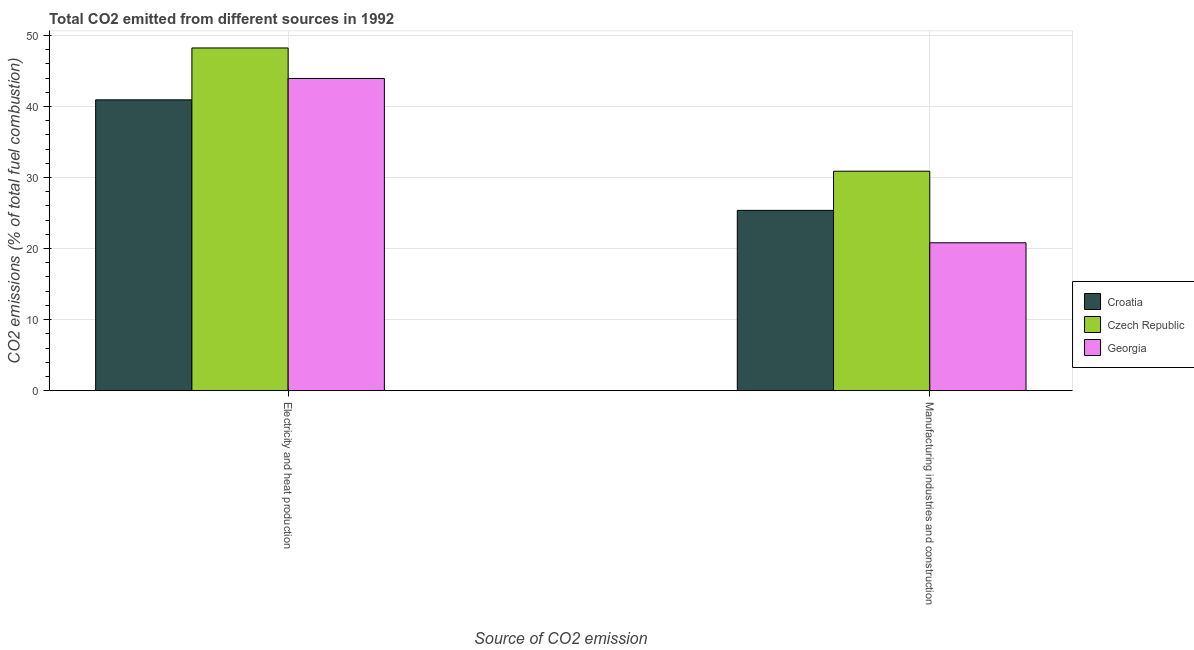How many different coloured bars are there?
Make the answer very short. 3. How many groups of bars are there?
Provide a short and direct response. 2. Are the number of bars per tick equal to the number of legend labels?
Make the answer very short. Yes. Are the number of bars on each tick of the X-axis equal?
Keep it short and to the point. Yes. What is the label of the 2nd group of bars from the left?
Provide a short and direct response. Manufacturing industries and construction. What is the co2 emissions due to electricity and heat production in Czech Republic?
Provide a succinct answer. 48.24. Across all countries, what is the maximum co2 emissions due to manufacturing industries?
Your response must be concise. 30.89. Across all countries, what is the minimum co2 emissions due to electricity and heat production?
Ensure brevity in your answer.  40.94. In which country was the co2 emissions due to manufacturing industries maximum?
Offer a very short reply. Czech Republic. In which country was the co2 emissions due to manufacturing industries minimum?
Your answer should be very brief. Georgia. What is the total co2 emissions due to electricity and heat production in the graph?
Offer a very short reply. 133.12. What is the difference between the co2 emissions due to manufacturing industries in Czech Republic and that in Croatia?
Provide a succinct answer. 5.51. What is the difference between the co2 emissions due to manufacturing industries in Georgia and the co2 emissions due to electricity and heat production in Czech Republic?
Provide a short and direct response. -27.43. What is the average co2 emissions due to manufacturing industries per country?
Keep it short and to the point. 25.69. What is the difference between the co2 emissions due to manufacturing industries and co2 emissions due to electricity and heat production in Czech Republic?
Your answer should be compact. -17.35. What is the ratio of the co2 emissions due to manufacturing industries in Czech Republic to that in Croatia?
Provide a short and direct response. 1.22. Is the co2 emissions due to manufacturing industries in Georgia less than that in Czech Republic?
Make the answer very short. Yes. What does the 1st bar from the left in Manufacturing industries and construction represents?
Make the answer very short. Croatia. What does the 2nd bar from the right in Electricity and heat production represents?
Your response must be concise. Czech Republic. Where does the legend appear in the graph?
Offer a very short reply. Center right. How many legend labels are there?
Keep it short and to the point. 3. What is the title of the graph?
Provide a short and direct response. Total CO2 emitted from different sources in 1992. What is the label or title of the X-axis?
Keep it short and to the point. Source of CO2 emission. What is the label or title of the Y-axis?
Your response must be concise. CO2 emissions (% of total fuel combustion). What is the CO2 emissions (% of total fuel combustion) of Croatia in Electricity and heat production?
Offer a very short reply. 40.94. What is the CO2 emissions (% of total fuel combustion) of Czech Republic in Electricity and heat production?
Offer a very short reply. 48.24. What is the CO2 emissions (% of total fuel combustion) of Georgia in Electricity and heat production?
Offer a terse response. 43.94. What is the CO2 emissions (% of total fuel combustion) of Croatia in Manufacturing industries and construction?
Keep it short and to the point. 25.38. What is the CO2 emissions (% of total fuel combustion) in Czech Republic in Manufacturing industries and construction?
Your answer should be compact. 30.89. What is the CO2 emissions (% of total fuel combustion) of Georgia in Manufacturing industries and construction?
Provide a succinct answer. 20.81. Across all Source of CO2 emission, what is the maximum CO2 emissions (% of total fuel combustion) in Croatia?
Provide a short and direct response. 40.94. Across all Source of CO2 emission, what is the maximum CO2 emissions (% of total fuel combustion) of Czech Republic?
Your response must be concise. 48.24. Across all Source of CO2 emission, what is the maximum CO2 emissions (% of total fuel combustion) of Georgia?
Make the answer very short. 43.94. Across all Source of CO2 emission, what is the minimum CO2 emissions (% of total fuel combustion) of Croatia?
Offer a terse response. 25.38. Across all Source of CO2 emission, what is the minimum CO2 emissions (% of total fuel combustion) in Czech Republic?
Keep it short and to the point. 30.89. Across all Source of CO2 emission, what is the minimum CO2 emissions (% of total fuel combustion) in Georgia?
Offer a terse response. 20.81. What is the total CO2 emissions (% of total fuel combustion) in Croatia in the graph?
Keep it short and to the point. 66.32. What is the total CO2 emissions (% of total fuel combustion) of Czech Republic in the graph?
Ensure brevity in your answer.  79.13. What is the total CO2 emissions (% of total fuel combustion) in Georgia in the graph?
Offer a very short reply. 64.76. What is the difference between the CO2 emissions (% of total fuel combustion) of Croatia in Electricity and heat production and that in Manufacturing industries and construction?
Make the answer very short. 15.56. What is the difference between the CO2 emissions (% of total fuel combustion) in Czech Republic in Electricity and heat production and that in Manufacturing industries and construction?
Provide a short and direct response. 17.35. What is the difference between the CO2 emissions (% of total fuel combustion) in Georgia in Electricity and heat production and that in Manufacturing industries and construction?
Your answer should be compact. 23.13. What is the difference between the CO2 emissions (% of total fuel combustion) in Croatia in Electricity and heat production and the CO2 emissions (% of total fuel combustion) in Czech Republic in Manufacturing industries and construction?
Keep it short and to the point. 10.05. What is the difference between the CO2 emissions (% of total fuel combustion) of Croatia in Electricity and heat production and the CO2 emissions (% of total fuel combustion) of Georgia in Manufacturing industries and construction?
Your answer should be very brief. 20.12. What is the difference between the CO2 emissions (% of total fuel combustion) in Czech Republic in Electricity and heat production and the CO2 emissions (% of total fuel combustion) in Georgia in Manufacturing industries and construction?
Keep it short and to the point. 27.43. What is the average CO2 emissions (% of total fuel combustion) in Croatia per Source of CO2 emission?
Your answer should be very brief. 33.16. What is the average CO2 emissions (% of total fuel combustion) in Czech Republic per Source of CO2 emission?
Make the answer very short. 39.57. What is the average CO2 emissions (% of total fuel combustion) of Georgia per Source of CO2 emission?
Offer a terse response. 32.38. What is the difference between the CO2 emissions (% of total fuel combustion) in Croatia and CO2 emissions (% of total fuel combustion) in Czech Republic in Electricity and heat production?
Ensure brevity in your answer.  -7.3. What is the difference between the CO2 emissions (% of total fuel combustion) in Croatia and CO2 emissions (% of total fuel combustion) in Georgia in Electricity and heat production?
Ensure brevity in your answer.  -3.01. What is the difference between the CO2 emissions (% of total fuel combustion) of Czech Republic and CO2 emissions (% of total fuel combustion) of Georgia in Electricity and heat production?
Offer a very short reply. 4.3. What is the difference between the CO2 emissions (% of total fuel combustion) of Croatia and CO2 emissions (% of total fuel combustion) of Czech Republic in Manufacturing industries and construction?
Provide a succinct answer. -5.51. What is the difference between the CO2 emissions (% of total fuel combustion) of Croatia and CO2 emissions (% of total fuel combustion) of Georgia in Manufacturing industries and construction?
Provide a succinct answer. 4.56. What is the difference between the CO2 emissions (% of total fuel combustion) in Czech Republic and CO2 emissions (% of total fuel combustion) in Georgia in Manufacturing industries and construction?
Ensure brevity in your answer.  10.08. What is the ratio of the CO2 emissions (% of total fuel combustion) in Croatia in Electricity and heat production to that in Manufacturing industries and construction?
Your answer should be compact. 1.61. What is the ratio of the CO2 emissions (% of total fuel combustion) of Czech Republic in Electricity and heat production to that in Manufacturing industries and construction?
Offer a very short reply. 1.56. What is the ratio of the CO2 emissions (% of total fuel combustion) in Georgia in Electricity and heat production to that in Manufacturing industries and construction?
Your answer should be very brief. 2.11. What is the difference between the highest and the second highest CO2 emissions (% of total fuel combustion) of Croatia?
Make the answer very short. 15.56. What is the difference between the highest and the second highest CO2 emissions (% of total fuel combustion) in Czech Republic?
Your response must be concise. 17.35. What is the difference between the highest and the second highest CO2 emissions (% of total fuel combustion) in Georgia?
Offer a very short reply. 23.13. What is the difference between the highest and the lowest CO2 emissions (% of total fuel combustion) in Croatia?
Give a very brief answer. 15.56. What is the difference between the highest and the lowest CO2 emissions (% of total fuel combustion) in Czech Republic?
Offer a very short reply. 17.35. What is the difference between the highest and the lowest CO2 emissions (% of total fuel combustion) of Georgia?
Ensure brevity in your answer.  23.13. 